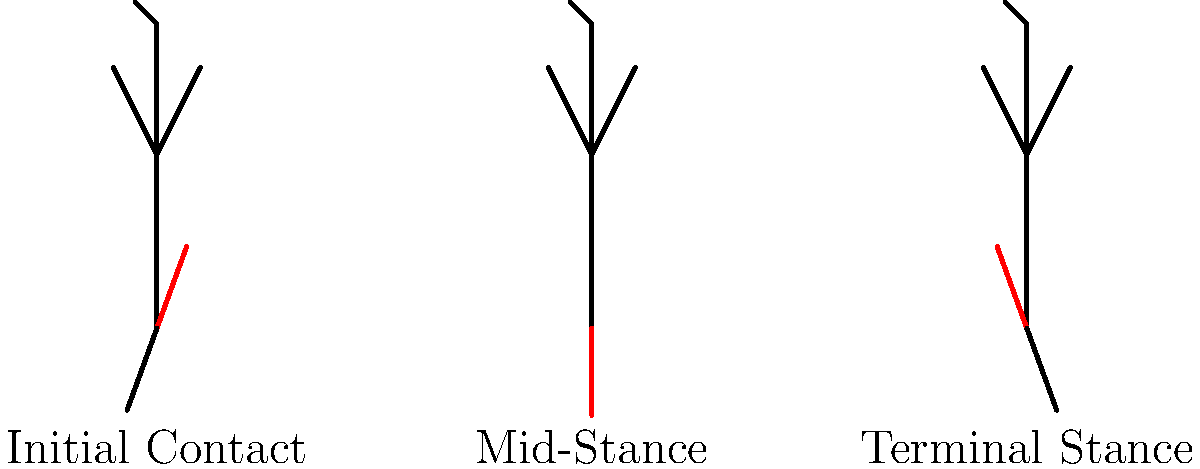Analyze the gait cycle illustrated by the stick figures above. Which phase of gait is characterized by increased knee flexion and hip extension, and what potential issue might this pattern indicate in an orthopedic rehabilitation context? To answer this question, let's analyze each phase of the gait cycle shown in the illustration:

1. Initial Contact: The first stick figure shows the beginning of the stance phase. The red leg is in front, indicating initial contact with the ground. The knee is slightly flexed, and the hip is in a neutral position.

2. Mid-Stance: The second stick figure represents the mid-stance phase. The red leg is now directly under the body, bearing full weight. The knee appears to be in a more extended position compared to the initial contact.

3. Terminal Stance: The third stick figure shows the terminal stance phase. Here, we can observe:
   a. Increased knee flexion in the red leg compared to the mid-stance position.
   b. The hip appears to be in an extended position, as the trunk is leaning slightly forward.

The phase characterized by increased knee flexion and hip extension is the Terminal Stance phase. 

In an orthopedic rehabilitation context, this pattern might indicate:

1. Quadriceps weakness: Increased knee flexion during terminal stance could suggest inadequate quadriceps strength to maintain knee extension.

2. Compensatory mechanism: The increased hip extension might be a compensatory movement to maintain balance and propulsion in the presence of knee instability or weakness.

3. Potential knee pathology: This gait pattern could be associated with conditions such as patellofemoral pain syndrome or osteoarthritis, where increased knee flexion helps to reduce joint stress.

4. Altered proprioception: Changes in joint position sense could lead to this altered gait pattern, potentially due to previous injury or surgery.

5. Ankle dorsiflexion limitation: Increased knee flexion might compensate for restricted ankle motion during push-off.
Answer: Terminal Stance; potential quadriceps weakness or knee pathology 